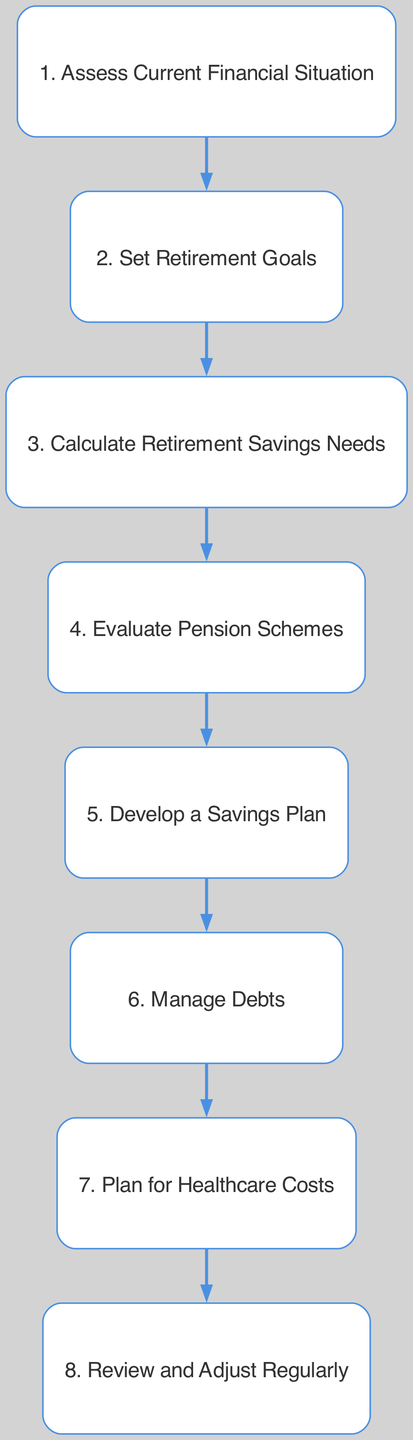What is the first step in the retirement financial planning flow chart? The first node in the flow chart is labeled "1. Assess Current Financial Situation", indicating it is the first step.
Answer: Assess Current Financial Situation How many total steps are there in the flow chart? By counting the nodes listed in the diagram, there are eight steps in total, each corresponding to one node.
Answer: 8 Which step involves evaluating pension schemes? The step titled "Evaluate Pension Schemes" is identified as step number four in the flow chart, indicating its position and relevance.
Answer: Evaluate Pension Schemes What is the last step in the diagram? The last node in the flow chart is labeled "8. Review and Adjust Regularly", which marks the final step in the planning process.
Answer: Review and Adjust Regularly What is done after calculating retirement savings needs? After calculating retirement savings needs, the next step in the flow chart is to "Evaluate Pension Schemes", indicating the sequence of actions.
Answer: Evaluate Pension Schemes How does one prioritize financial obligations in retirement? The flow chart outlines "Manage Debts" as step six, which suggests this step involves planning and prioritizing debt repayment.
Answer: Manage Debts Which steps focus on planning and preparation? Steps two through five: "Set Retirement Goals", "Calculate Retirement Savings Needs", "Evaluate Pension Schemes", and "Develop a Savings Plan" all relate to planning and preparation for retirement.
Answer: Set Retirement Goals, Calculate Retirement Savings Needs, Evaluate Pension Schemes, Develop a Savings Plan What might you need to consider regarding healthcare costs? The step titled "Plan for Healthcare Costs" addresses considerations around healthcare expenses and insurance options in retirement planning.
Answer: Plan for Healthcare Costs What is the primary purpose of the flow chart? The primary purpose of the flow chart is to outline a structured approach to "Retirement Financial Planning" to secure a person's future financial well-being.
Answer: Structured approach to Retirement Financial Planning 